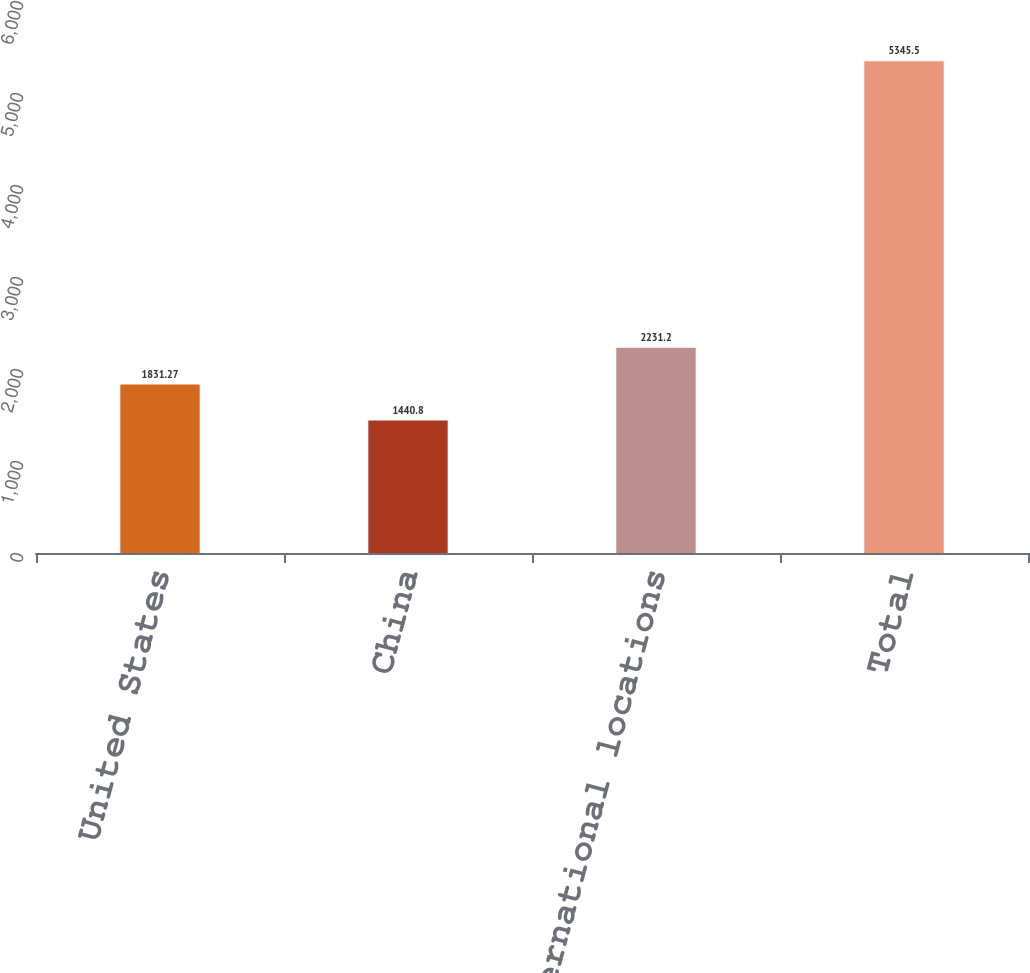<chart> <loc_0><loc_0><loc_500><loc_500><bar_chart><fcel>United States<fcel>China<fcel>Other international locations<fcel>Total<nl><fcel>1831.27<fcel>1440.8<fcel>2231.2<fcel>5345.5<nl></chart> 